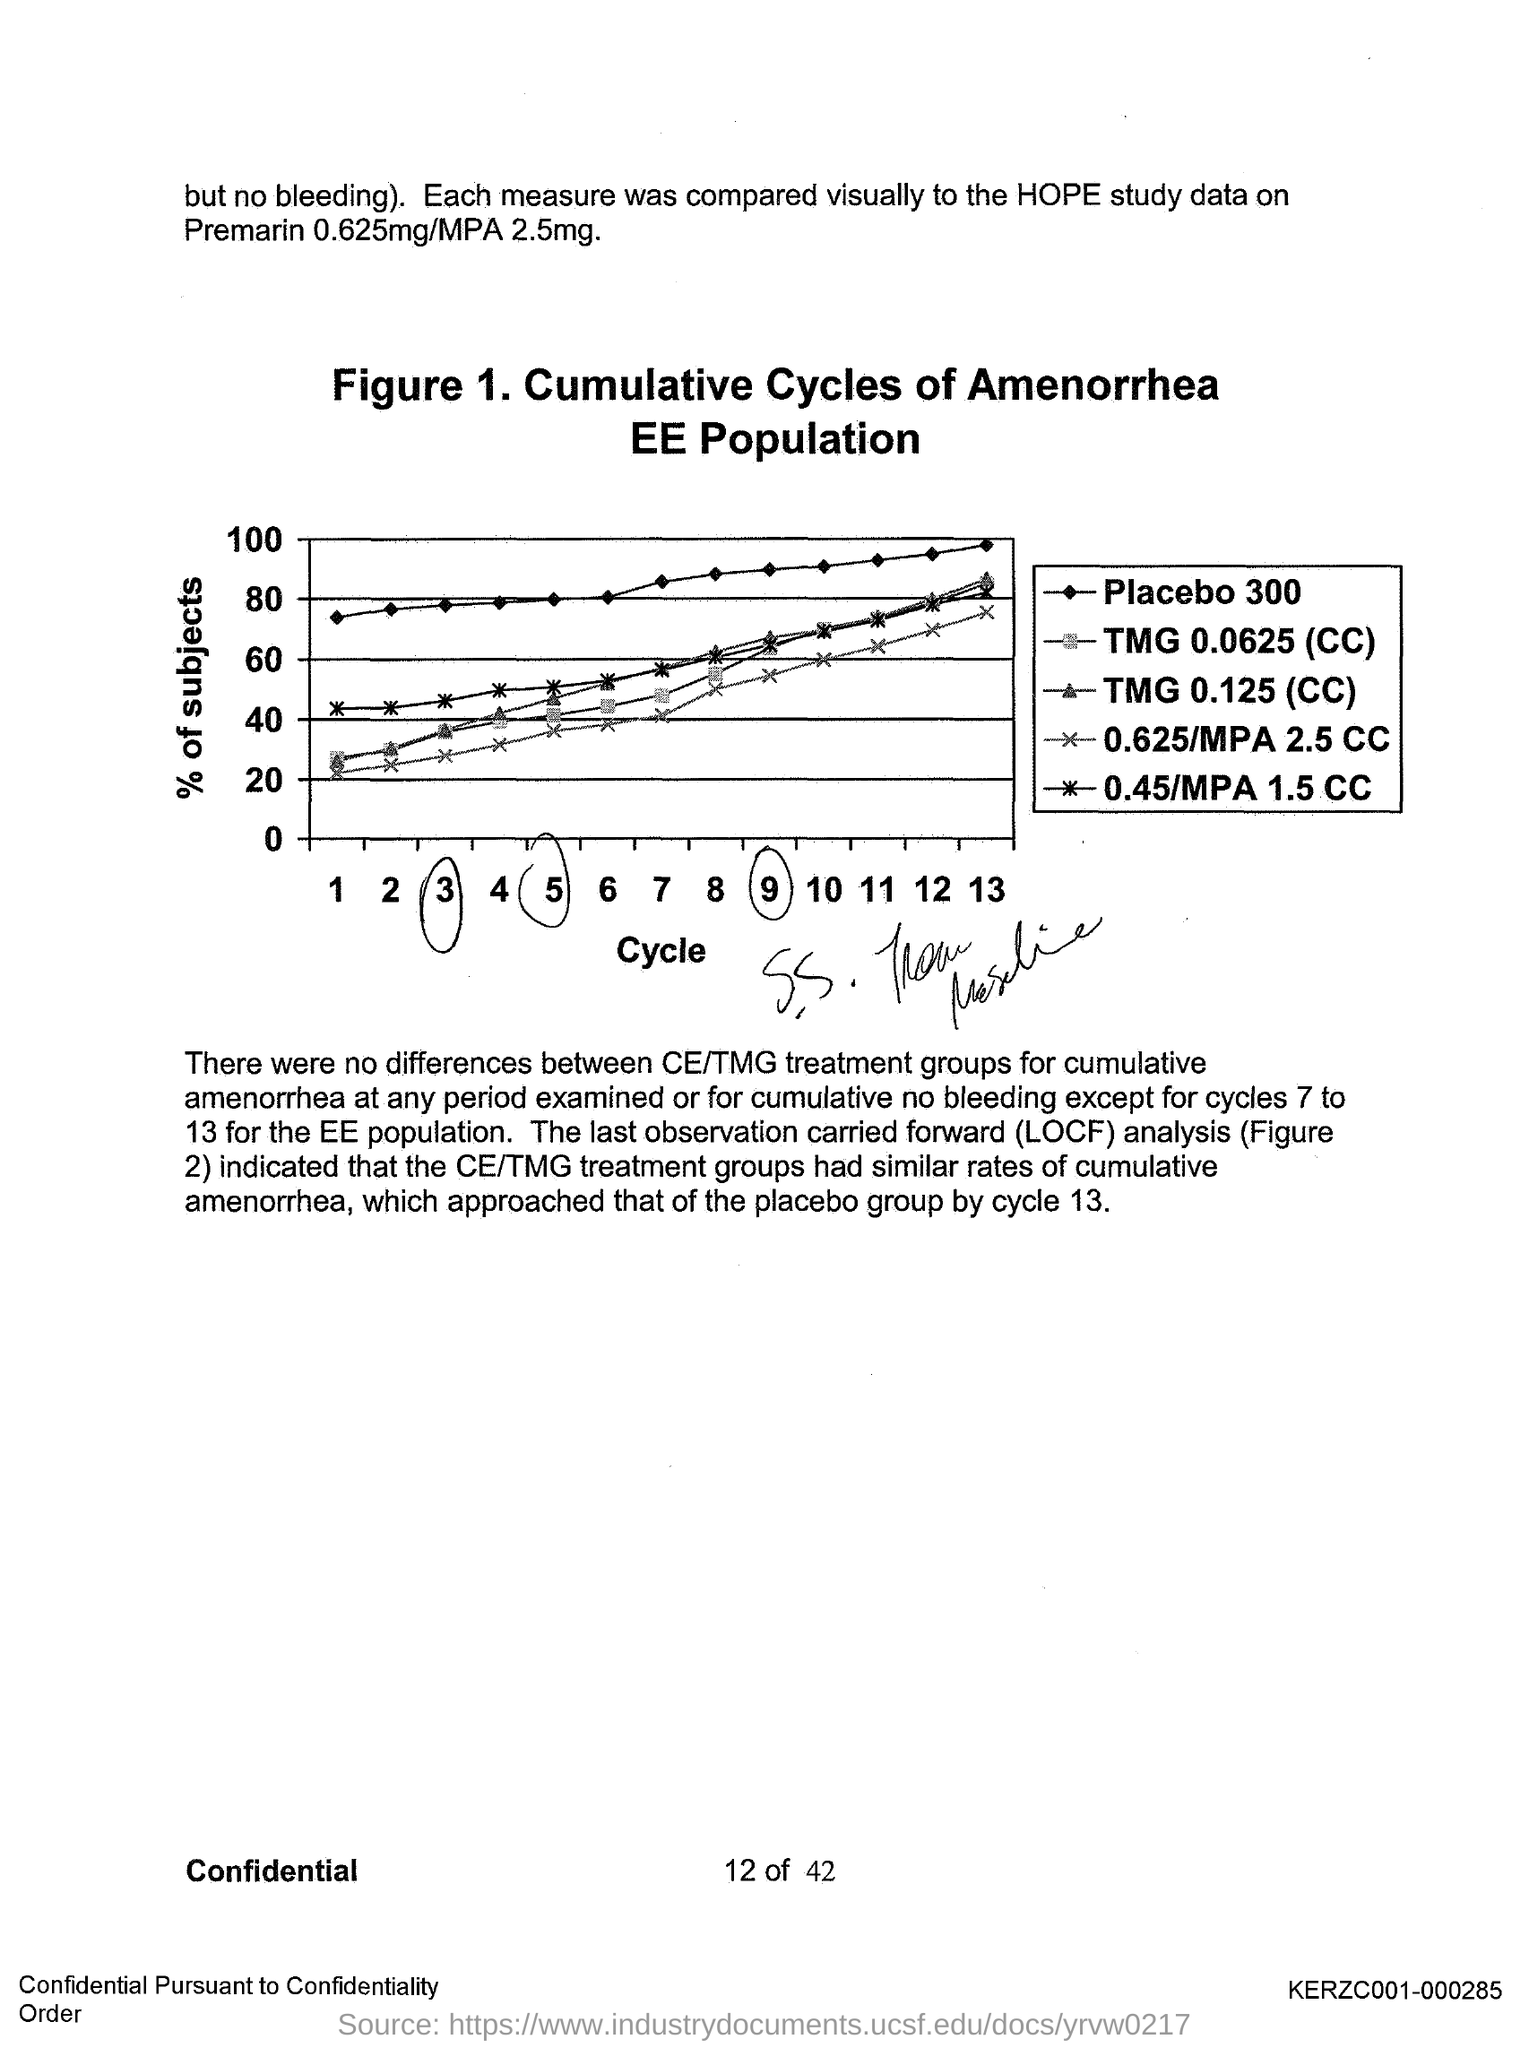Identify some key points in this picture. Figure 1 in this document represents cumulative cycles of amenorrhea. The acronym "LOCF" stands for "last observation carried forward," which is a method used in statistical analysis to handle missing data. 